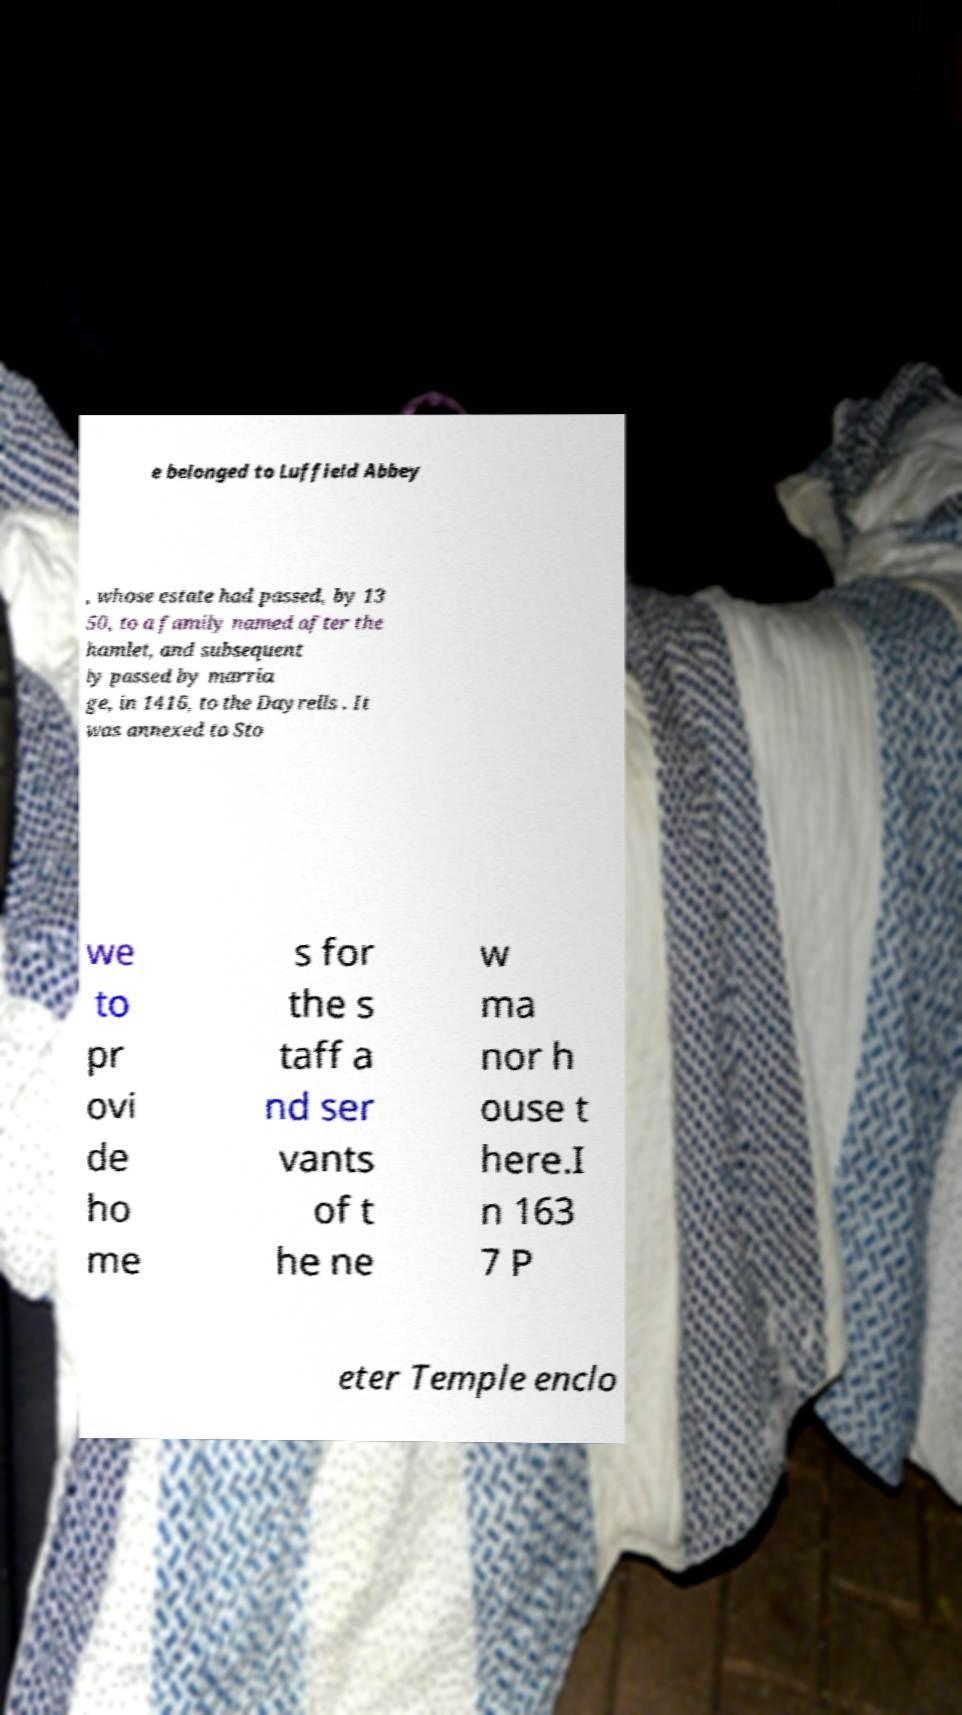Can you accurately transcribe the text from the provided image for me? e belonged to Luffield Abbey , whose estate had passed, by 13 50, to a family named after the hamlet, and subsequent ly passed by marria ge, in 1416, to the Dayrells . It was annexed to Sto we to pr ovi de ho me s for the s taff a nd ser vants of t he ne w ma nor h ouse t here.I n 163 7 P eter Temple enclo 